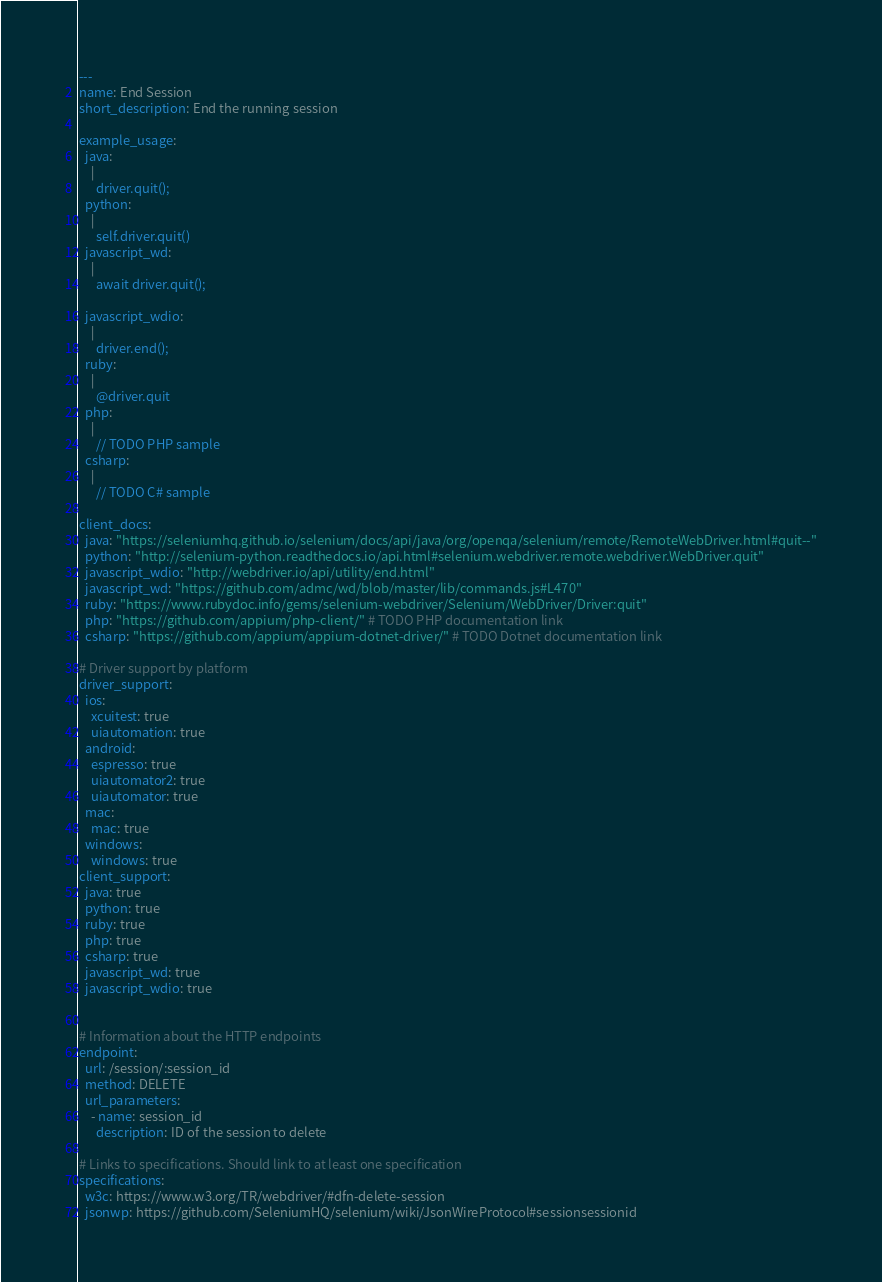<code> <loc_0><loc_0><loc_500><loc_500><_YAML_>---
name: End Session
short_description: End the running session
   
example_usage:
  java:
    |
      driver.quit();
  python:
    |
      self.driver.quit()
  javascript_wd:
    |
      await driver.quit();

  javascript_wdio:
    |
      driver.end();
  ruby:
    |
      @driver.quit
  php:
    |
      // TODO PHP sample
  csharp:
    |
      // TODO C# sample

client_docs:
  java: "https://seleniumhq.github.io/selenium/docs/api/java/org/openqa/selenium/remote/RemoteWebDriver.html#quit--"
  python: "http://selenium-python.readthedocs.io/api.html#selenium.webdriver.remote.webdriver.WebDriver.quit"
  javascript_wdio: "http://webdriver.io/api/utility/end.html"
  javascript_wd: "https://github.com/admc/wd/blob/master/lib/commands.js#L470"
  ruby: "https://www.rubydoc.info/gems/selenium-webdriver/Selenium/WebDriver/Driver:quit"
  php: "https://github.com/appium/php-client/" # TODO PHP documentation link
  csharp: "https://github.com/appium/appium-dotnet-driver/" # TODO Dotnet documentation link

# Driver support by platform
driver_support:
  ios:
    xcuitest: true
    uiautomation: true
  android:
    espresso: true
    uiautomator2: true
    uiautomator: true
  mac:
    mac: true
  windows:
    windows: true
client_support:
  java: true
  python: true
  ruby: true
  php: true
  csharp: true
  javascript_wd: true
  javascript_wdio: true
  

# Information about the HTTP endpoints
endpoint:
  url: /session/:session_id
  method: DELETE
  url_parameters:
    - name: session_id
      description: ID of the session to delete

# Links to specifications. Should link to at least one specification
specifications:
  w3c: https://www.w3.org/TR/webdriver/#dfn-delete-session
  jsonwp: https://github.com/SeleniumHQ/selenium/wiki/JsonWireProtocol#sessionsessionid
</code> 